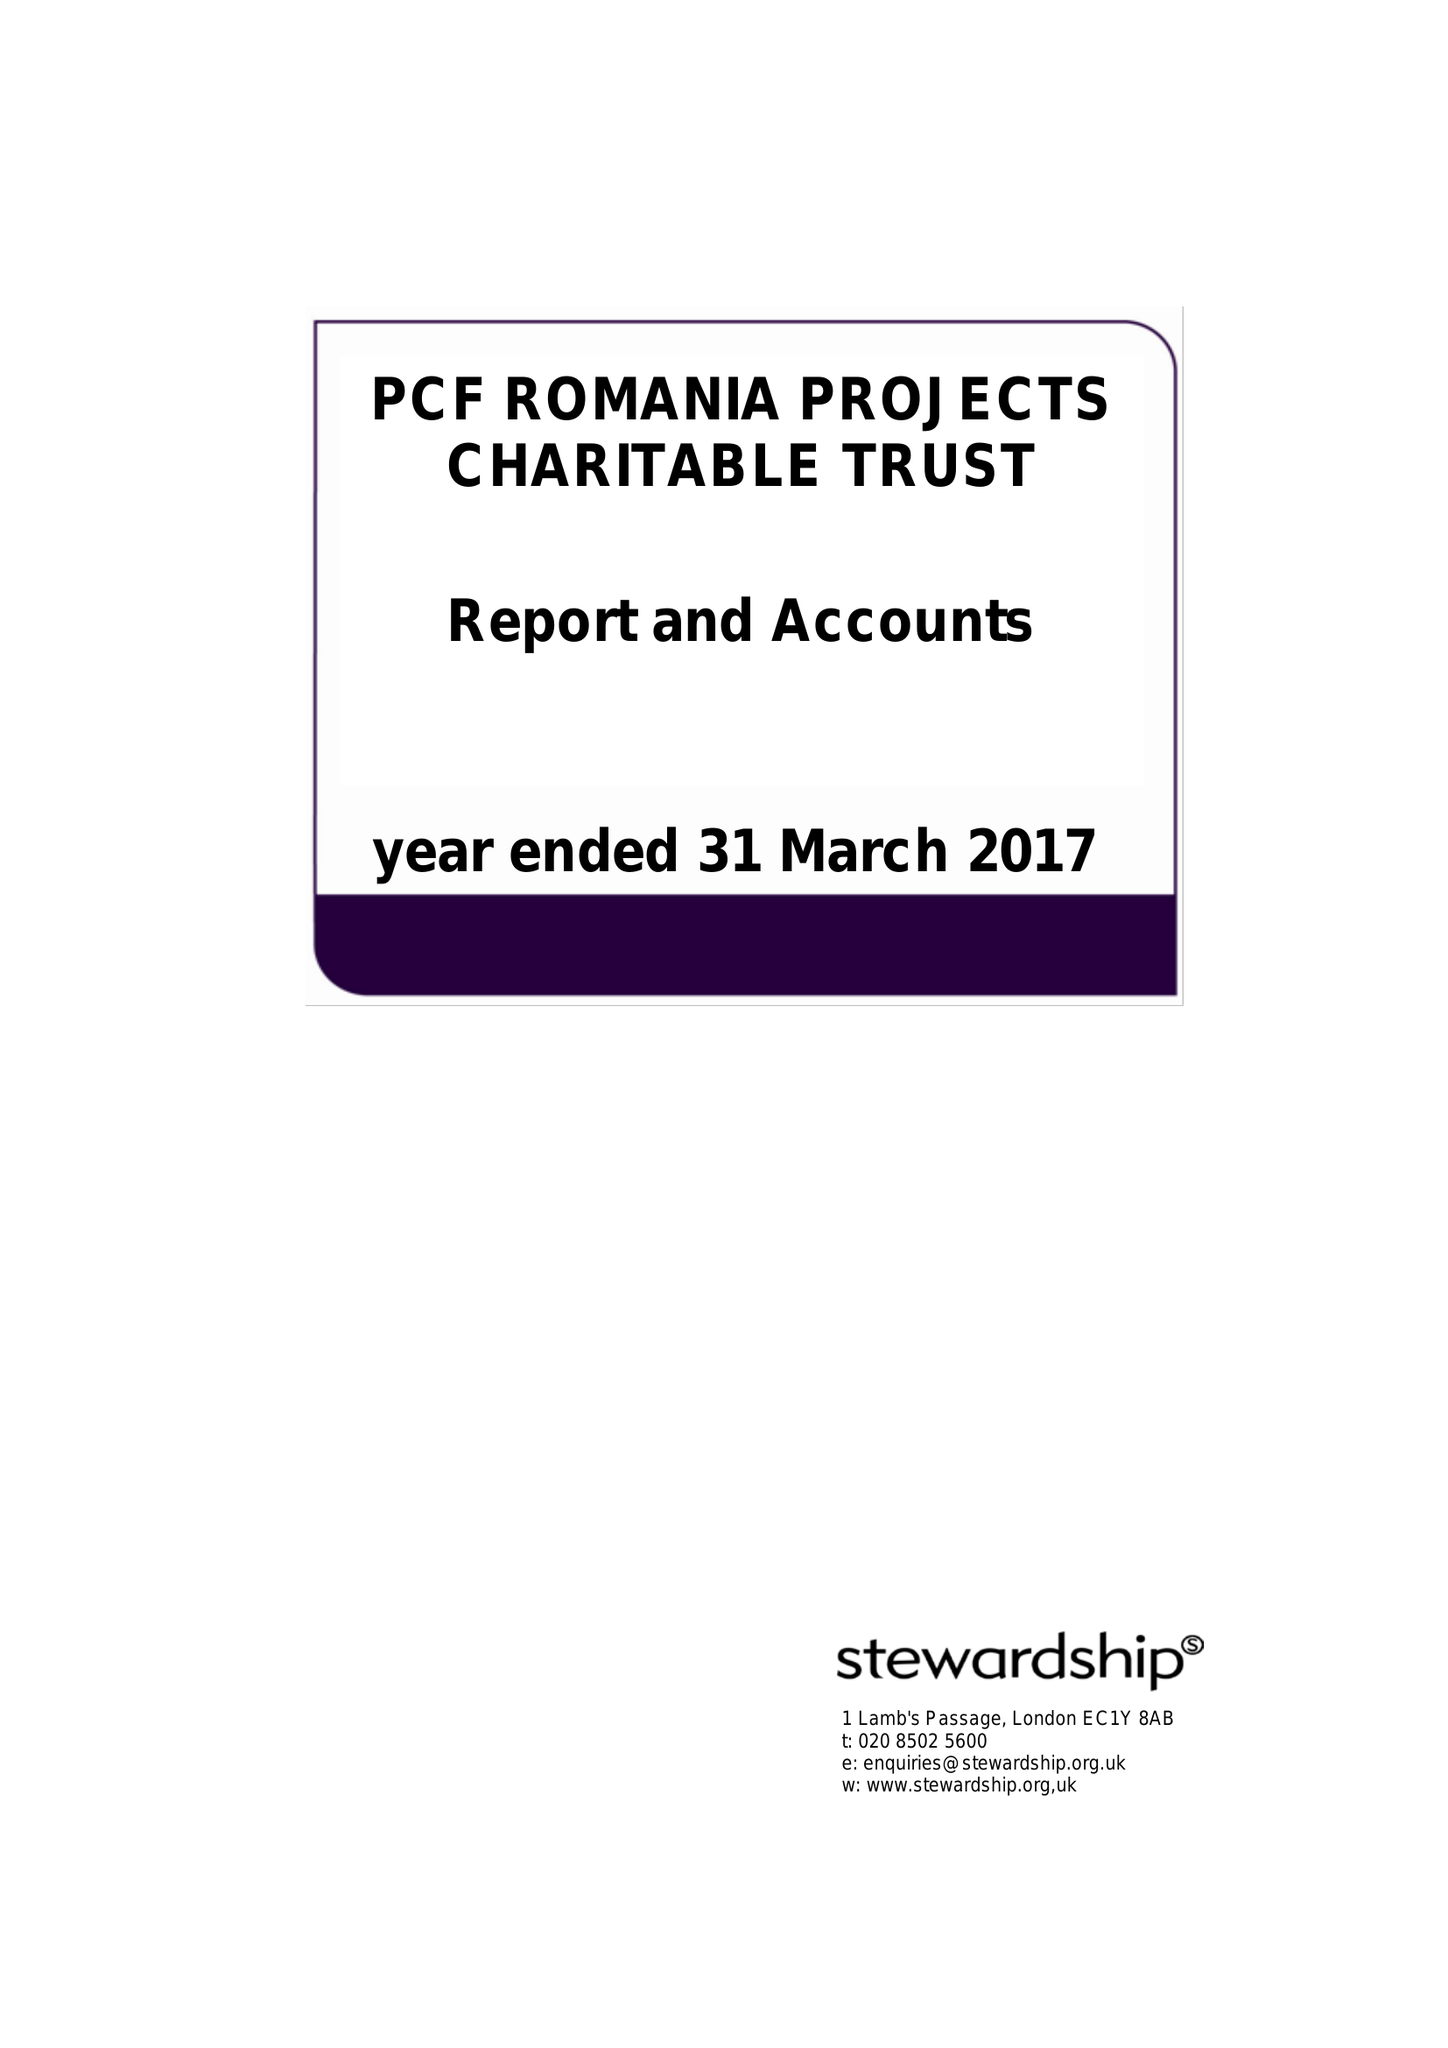What is the value for the charity_number?
Answer the question using a single word or phrase. 1114182 